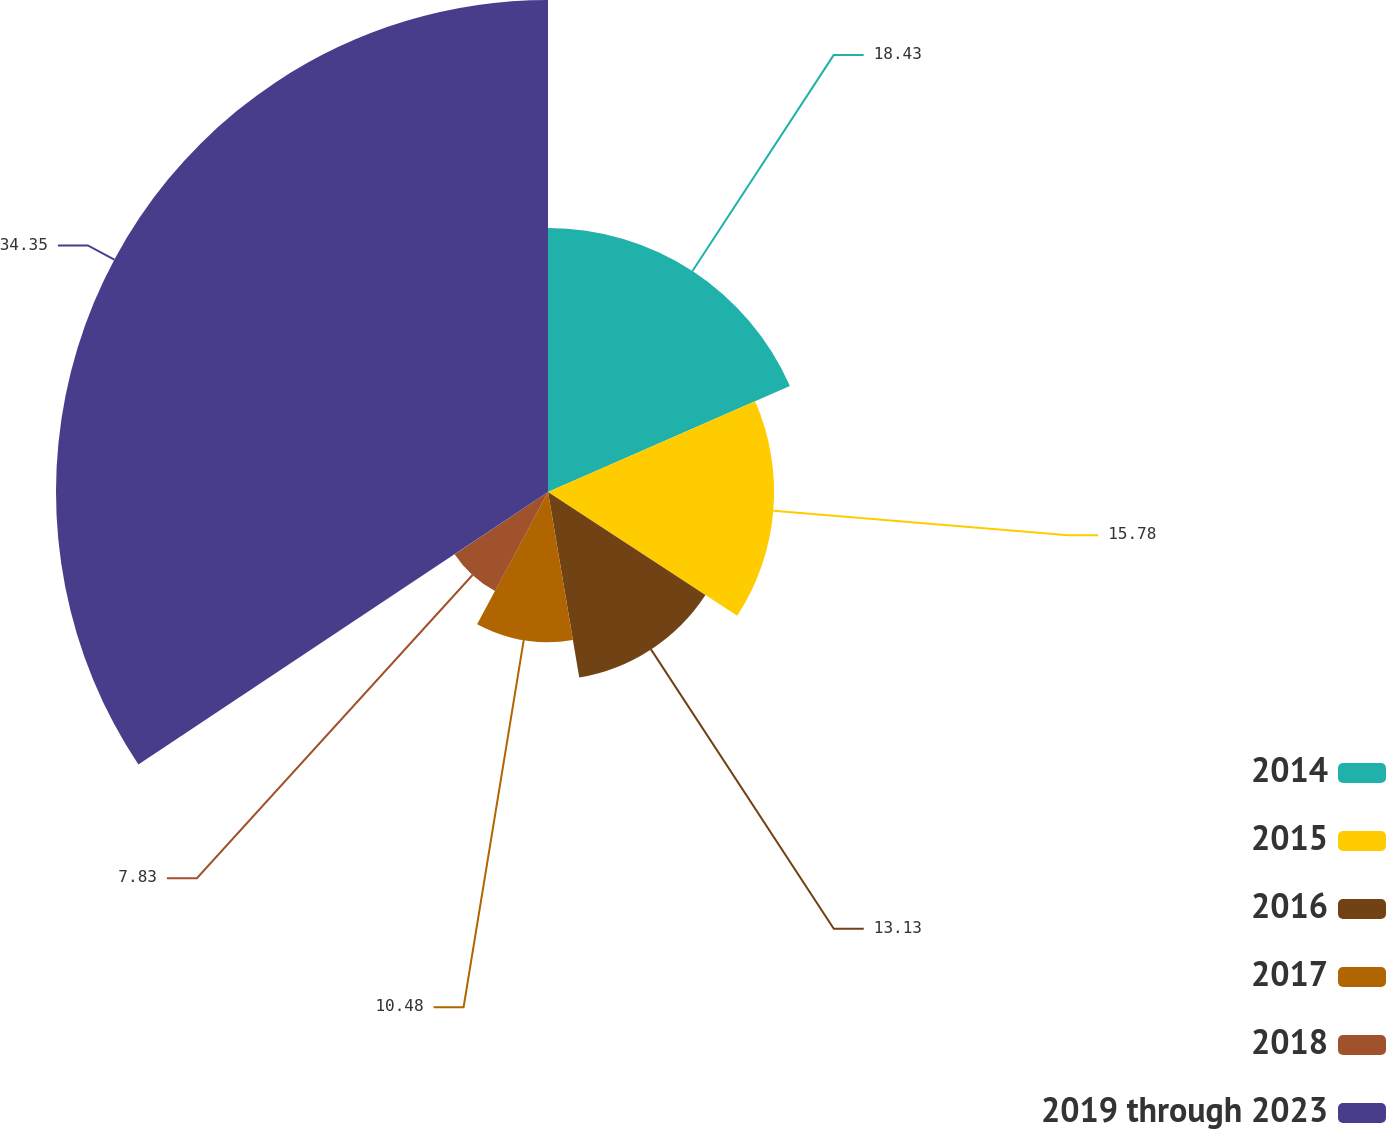<chart> <loc_0><loc_0><loc_500><loc_500><pie_chart><fcel>2014<fcel>2015<fcel>2016<fcel>2017<fcel>2018<fcel>2019 through 2023<nl><fcel>18.43%<fcel>15.78%<fcel>13.13%<fcel>10.48%<fcel>7.83%<fcel>34.34%<nl></chart> 